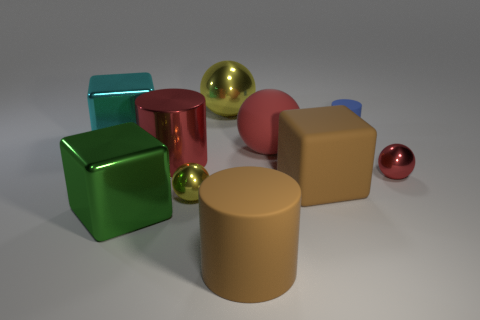There is a tiny yellow shiny ball; are there any big red things left of it?
Make the answer very short. Yes. There is a yellow metallic ball in front of the brown cube; how many brown blocks are in front of it?
Your answer should be compact. 0. There is a yellow thing that is made of the same material as the small yellow ball; what is its size?
Keep it short and to the point. Large. The blue cylinder is what size?
Provide a succinct answer. Small. Are the tiny red ball and the large green cube made of the same material?
Your answer should be very brief. Yes. How many spheres are cyan metal objects or small yellow shiny objects?
Your response must be concise. 1. What color is the rubber cylinder behind the large cylinder behind the tiny red metal ball?
Offer a very short reply. Blue. There is a metallic ball that is the same color as the large metallic cylinder; what size is it?
Your answer should be very brief. Small. There is a metallic block that is in front of the large object that is left of the large green shiny object; how many yellow objects are to the left of it?
Your answer should be compact. 0. There is a shiny thing that is behind the blue matte cylinder; is it the same shape as the blue object that is right of the big cyan metallic block?
Provide a short and direct response. No. 